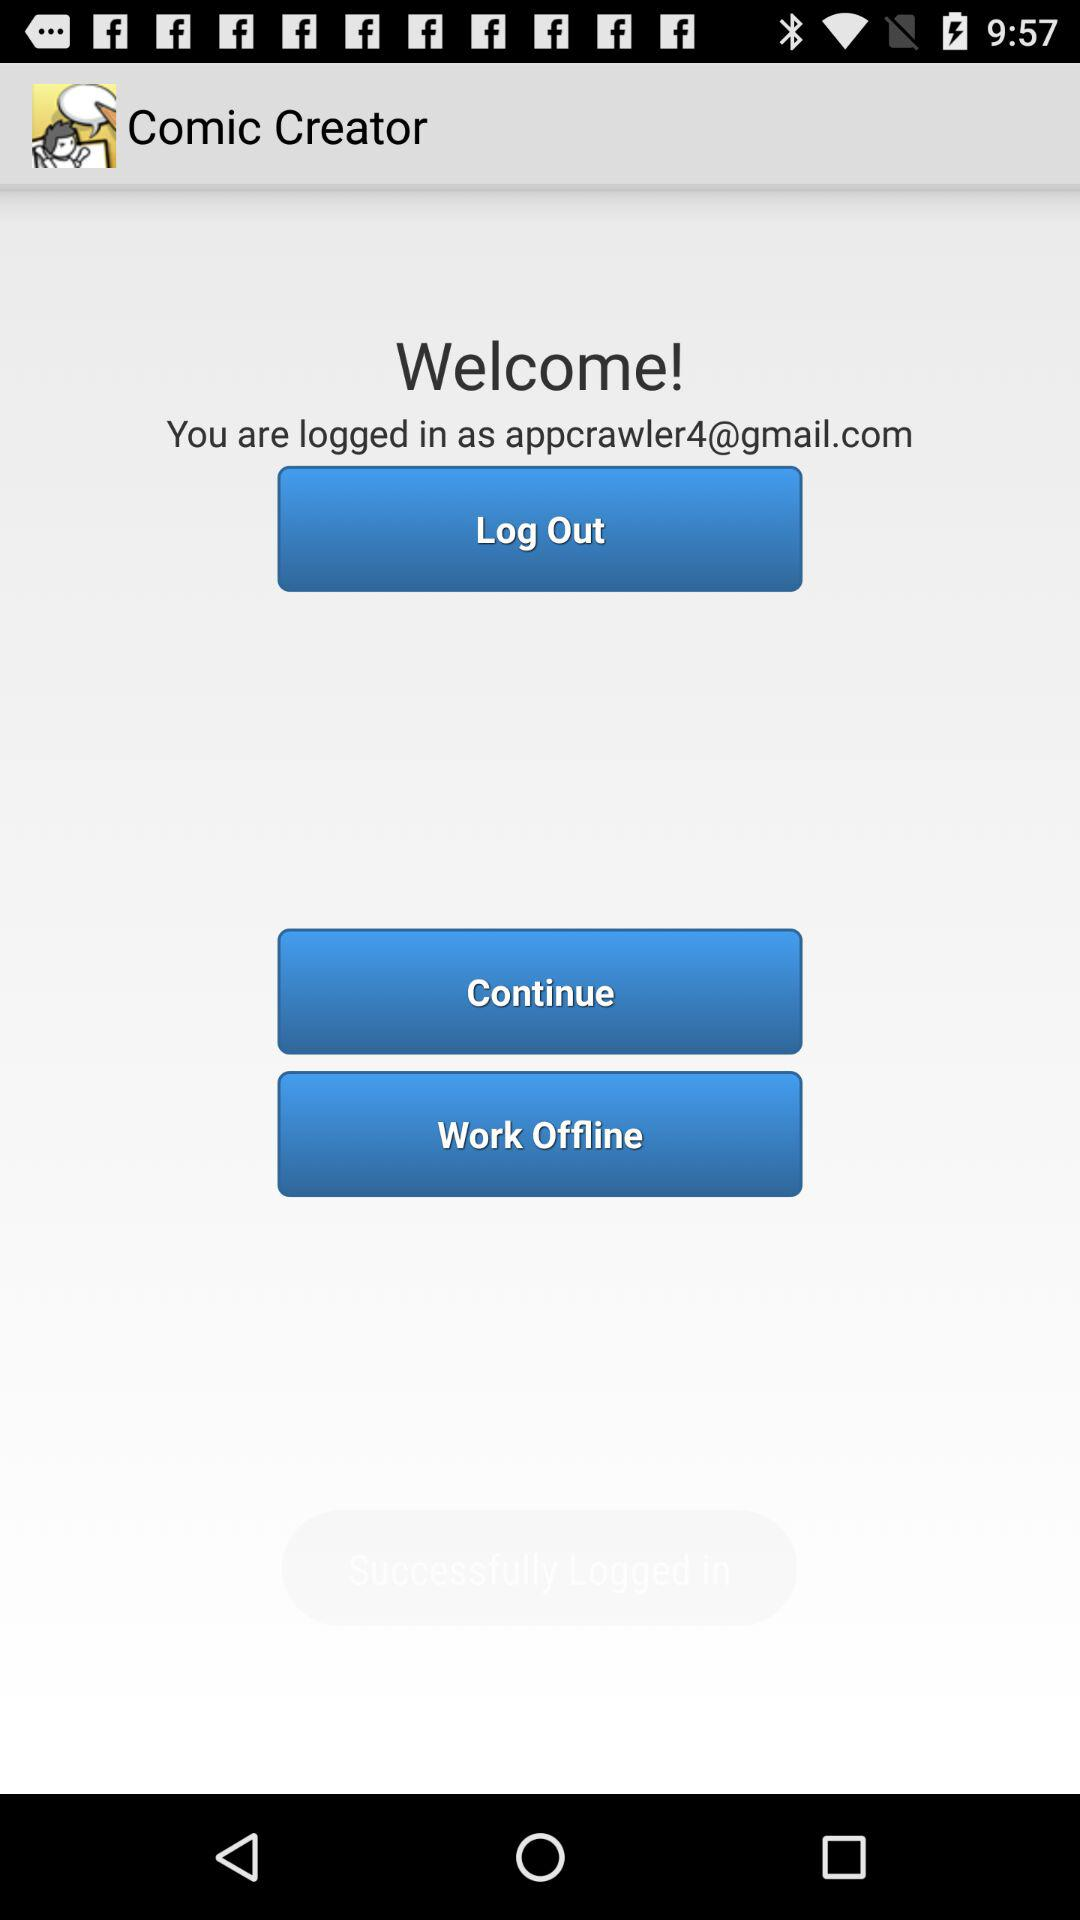What is an email address? The email address is appcrawler4@gmail.com. 